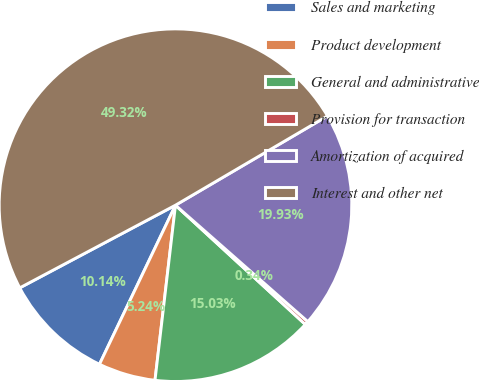Convert chart. <chart><loc_0><loc_0><loc_500><loc_500><pie_chart><fcel>Sales and marketing<fcel>Product development<fcel>General and administrative<fcel>Provision for transaction<fcel>Amortization of acquired<fcel>Interest and other net<nl><fcel>10.14%<fcel>5.24%<fcel>15.03%<fcel>0.34%<fcel>19.93%<fcel>49.32%<nl></chart> 